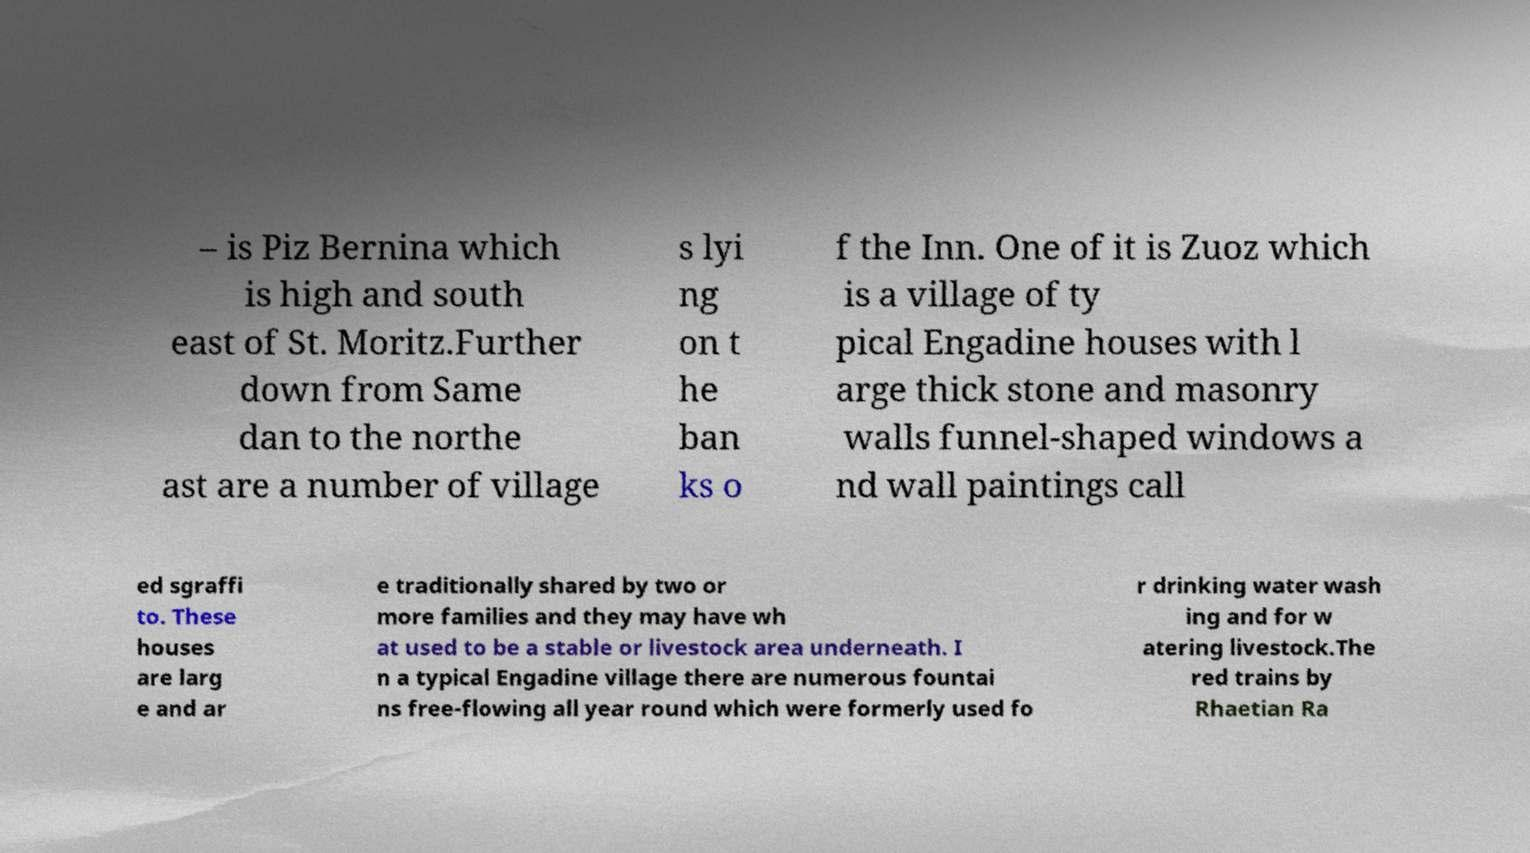Please read and relay the text visible in this image. What does it say? – is Piz Bernina which is high and south east of St. Moritz.Further down from Same dan to the northe ast are a number of village s lyi ng on t he ban ks o f the Inn. One of it is Zuoz which is a village of ty pical Engadine houses with l arge thick stone and masonry walls funnel-shaped windows a nd wall paintings call ed sgraffi to. These houses are larg e and ar e traditionally shared by two or more families and they may have wh at used to be a stable or livestock area underneath. I n a typical Engadine village there are numerous fountai ns free-flowing all year round which were formerly used fo r drinking water wash ing and for w atering livestock.The red trains by Rhaetian Ra 